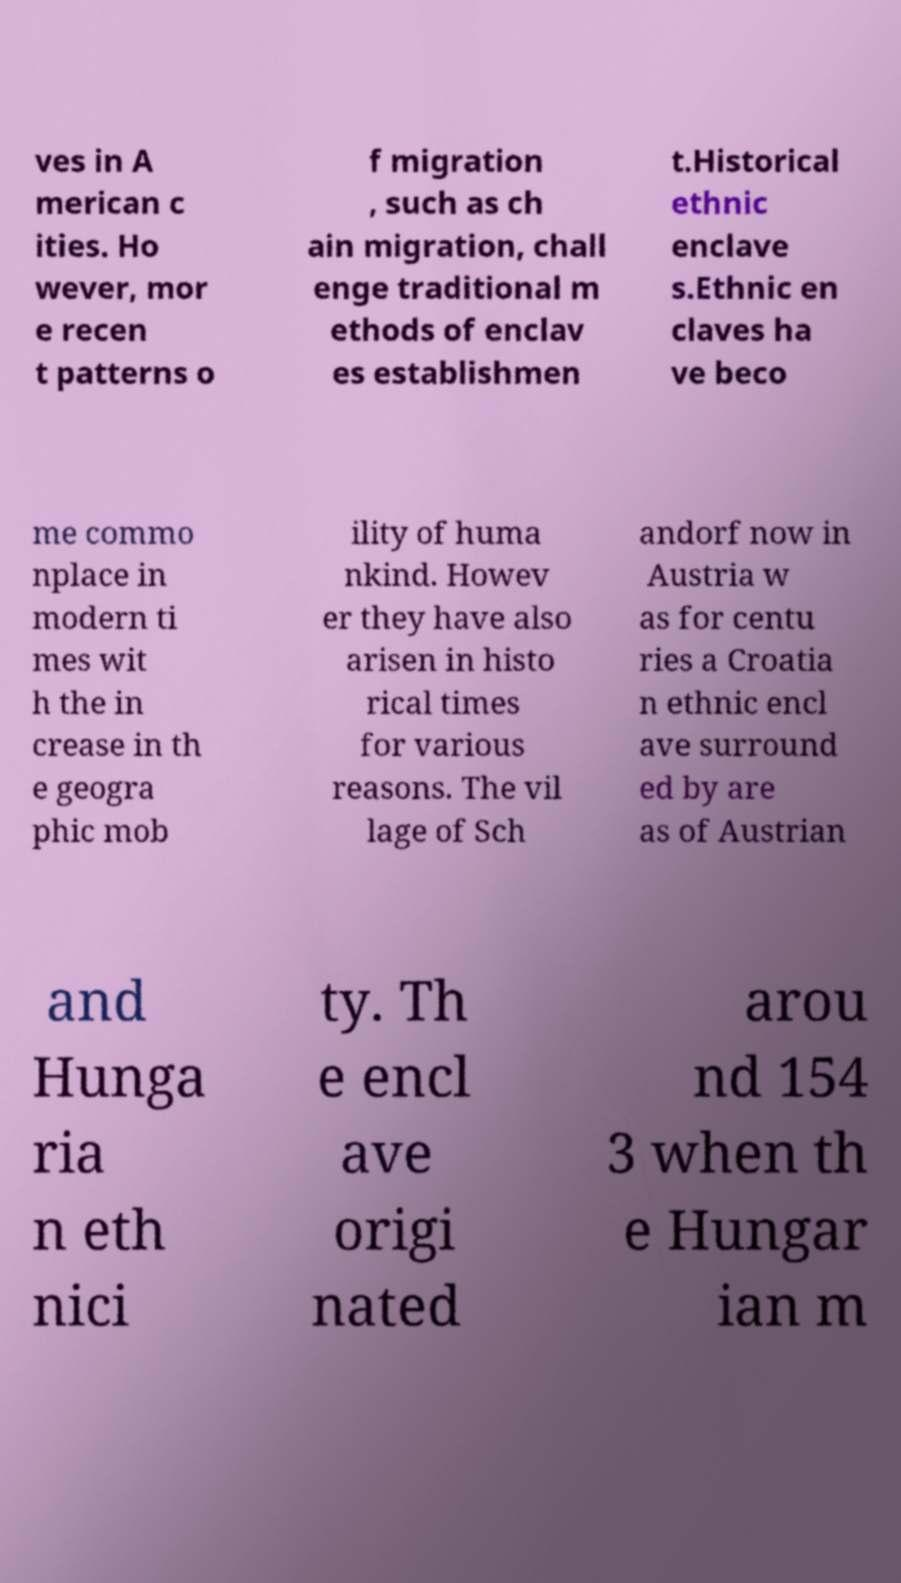For documentation purposes, I need the text within this image transcribed. Could you provide that? ves in A merican c ities. Ho wever, mor e recen t patterns o f migration , such as ch ain migration, chall enge traditional m ethods of enclav es establishmen t.Historical ethnic enclave s.Ethnic en claves ha ve beco me commo nplace in modern ti mes wit h the in crease in th e geogra phic mob ility of huma nkind. Howev er they have also arisen in histo rical times for various reasons. The vil lage of Sch andorf now in Austria w as for centu ries a Croatia n ethnic encl ave surround ed by are as of Austrian and Hunga ria n eth nici ty. Th e encl ave origi nated arou nd 154 3 when th e Hungar ian m 